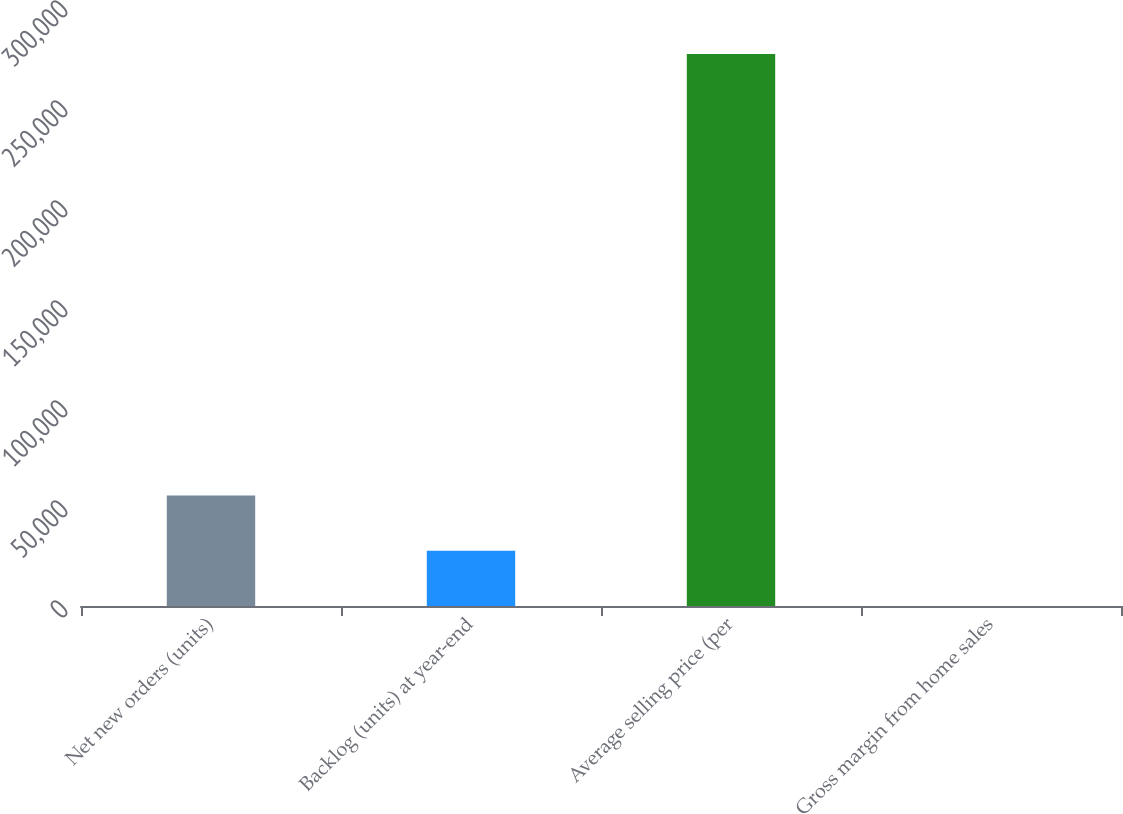Convert chart to OTSL. <chart><loc_0><loc_0><loc_500><loc_500><bar_chart><fcel>Net new orders (units)<fcel>Backlog (units) at year-end<fcel>Average selling price (per<fcel>Gross margin from home sales<nl><fcel>55212.6<fcel>27614.2<fcel>276000<fcel>15.8<nl></chart> 